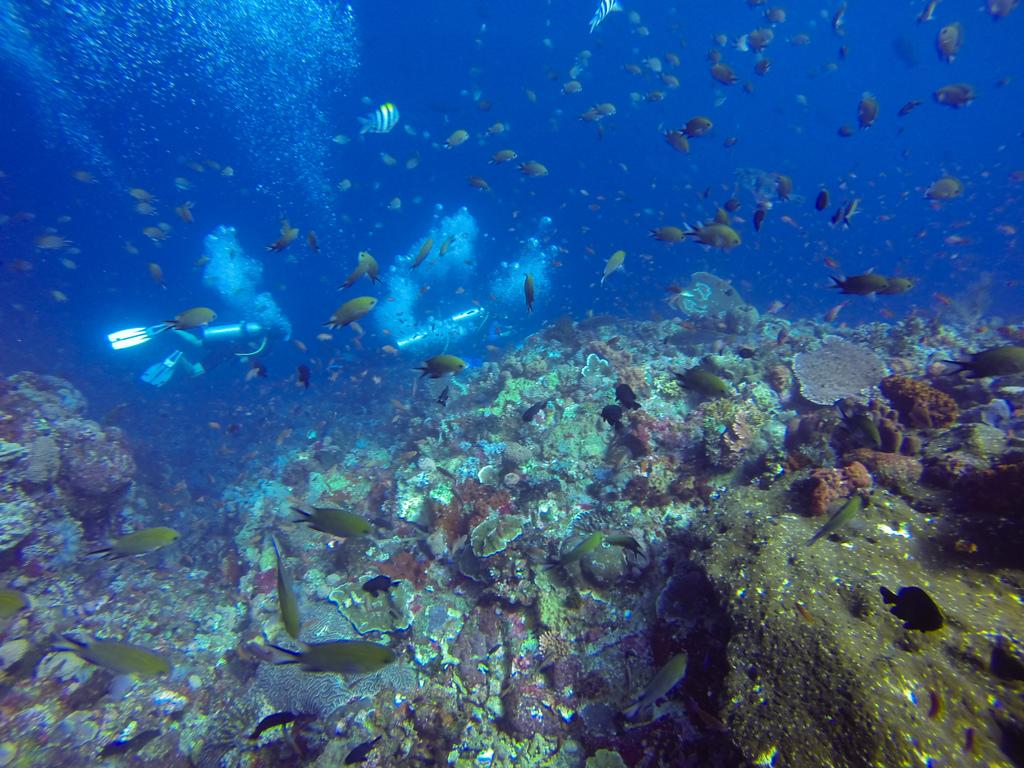What type of animals can be seen in the image? There are small fishes in the image. Where are the small fishes located? The small fishes are in the water. How many steps does the fish take to reach the surface of the water in the image? There are no steps in the image, as fish do not walk or take steps. 